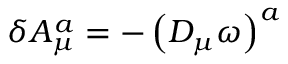<formula> <loc_0><loc_0><loc_500><loc_500>\delta A _ { \mu } ^ { a } = - \left ( D _ { \mu } \omega \right ) ^ { a }</formula> 